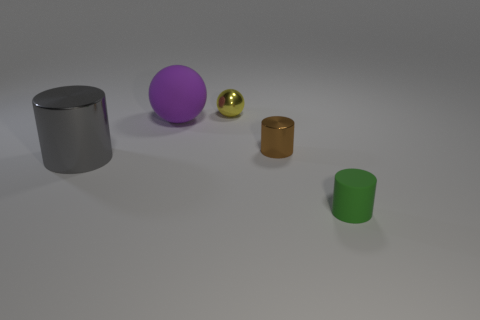Is the number of big gray cylinders that are to the right of the matte sphere greater than the number of cyan metallic objects?
Your response must be concise. No. Is there a small thing of the same color as the matte cylinder?
Your answer should be compact. No. What is the color of the matte object that is the same size as the shiny ball?
Your answer should be very brief. Green. Is there a tiny brown metal object to the right of the small cylinder that is in front of the small brown cylinder?
Make the answer very short. No. What material is the ball on the left side of the small yellow metallic sphere?
Make the answer very short. Rubber. Is the tiny cylinder behind the tiny green rubber object made of the same material as the ball in front of the small metal ball?
Keep it short and to the point. No. Are there the same number of matte objects that are behind the brown cylinder and purple objects to the left of the gray metal cylinder?
Make the answer very short. No. How many tiny yellow objects have the same material as the tiny yellow ball?
Give a very brief answer. 0. How big is the matte thing behind the rubber object that is right of the small yellow thing?
Give a very brief answer. Large. There is a matte object that is in front of the gray cylinder; is its shape the same as the tiny shiny object that is on the left side of the brown metallic object?
Keep it short and to the point. No. 